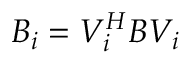Convert formula to latex. <formula><loc_0><loc_0><loc_500><loc_500>B _ { i } = V _ { i } ^ { H } B V _ { i }</formula> 